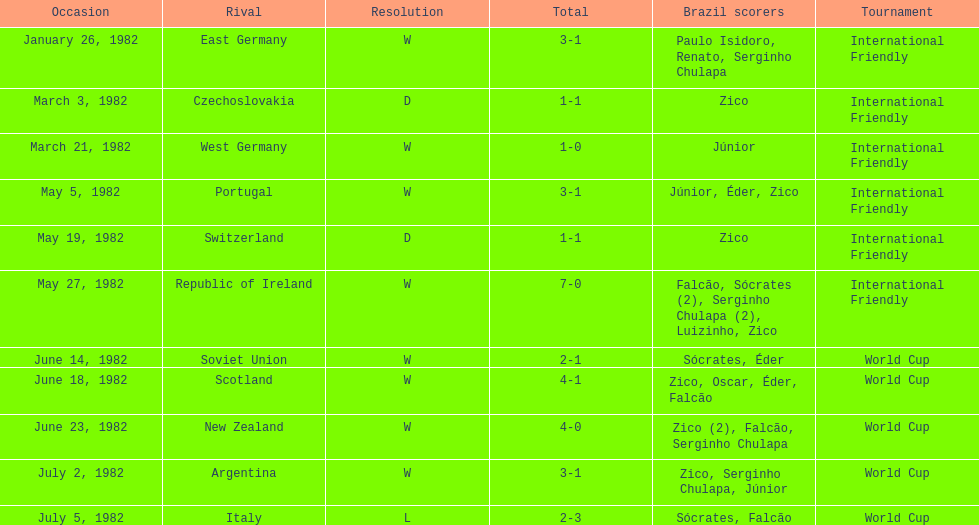Was the total goals scored on june 14, 1982 more than 6? No. Write the full table. {'header': ['Occasion', 'Rival', 'Resolution', 'Total', 'Brazil scorers', 'Tournament'], 'rows': [['January 26, 1982', 'East Germany', 'W', '3-1', 'Paulo Isidoro, Renato, Serginho Chulapa', 'International Friendly'], ['March 3, 1982', 'Czechoslovakia', 'D', '1-1', 'Zico', 'International Friendly'], ['March 21, 1982', 'West Germany', 'W', '1-0', 'Júnior', 'International Friendly'], ['May 5, 1982', 'Portugal', 'W', '3-1', 'Júnior, Éder, Zico', 'International Friendly'], ['May 19, 1982', 'Switzerland', 'D', '1-1', 'Zico', 'International Friendly'], ['May 27, 1982', 'Republic of Ireland', 'W', '7-0', 'Falcão, Sócrates (2), Serginho Chulapa (2), Luizinho, Zico', 'International Friendly'], ['June 14, 1982', 'Soviet Union', 'W', '2-1', 'Sócrates, Éder', 'World Cup'], ['June 18, 1982', 'Scotland', 'W', '4-1', 'Zico, Oscar, Éder, Falcão', 'World Cup'], ['June 23, 1982', 'New Zealand', 'W', '4-0', 'Zico (2), Falcão, Serginho Chulapa', 'World Cup'], ['July 2, 1982', 'Argentina', 'W', '3-1', 'Zico, Serginho Chulapa, Júnior', 'World Cup'], ['July 5, 1982', 'Italy', 'L', '2-3', 'Sócrates, Falcão', 'World Cup']]} 